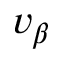<formula> <loc_0><loc_0><loc_500><loc_500>v _ { \beta }</formula> 